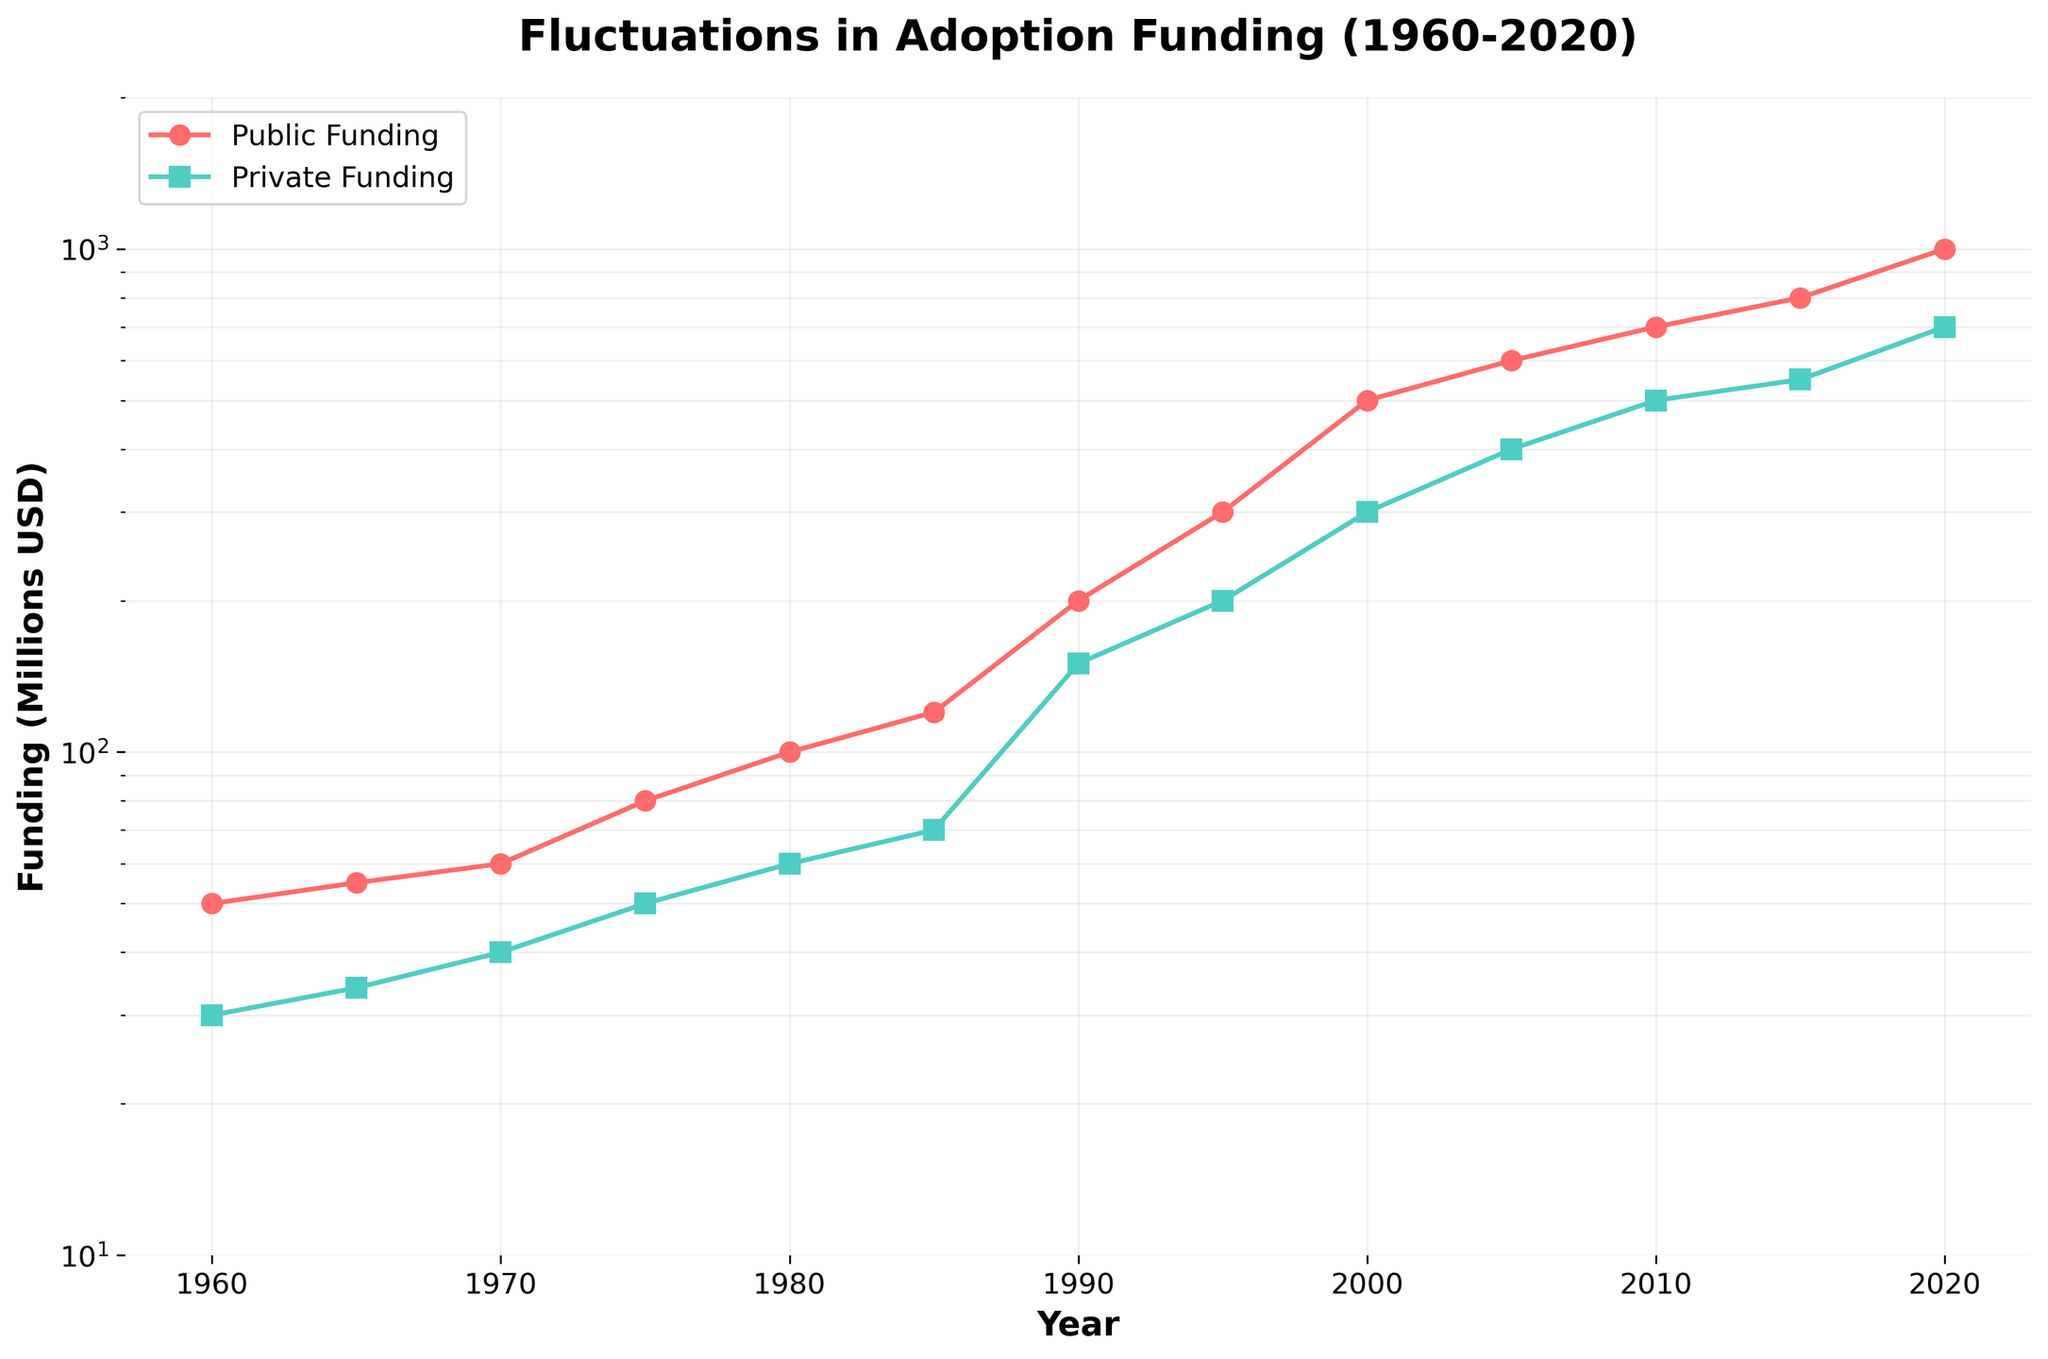What is the title of the figure? The title of the figure is located at the top of the plot and usually gives a brief description of the content being depicted. By referring to the visual information, we can see "Fluctuations in Adoption Funding (1960-2020)" is the title.
Answer: Fluctuations in Adoption Funding (1960-2020) What is the highest amount of public funding recorded and in which year? By examining the line plot for public funding (marked with circles and a red line), we see that the highest point on the y-axis corresponds to the year 2020, where the public funding reaches 1000 million USD.
Answer: 1000 million USD in 2020 How does private funding in 1990 compare to that in 2000? By locating the data points for the years 1990 and 2000 on the line representing private funding (marked with squares and a green line), we observe the values on the y-axis. In 1990, private funding was 150 million USD, and in 2000, it increased to 300 million USD. Hence, private funding doubled from 1990 to 2000.
Answer: Private funding doubled from 1990 to 2000 Between which years did public funding show the most significant increase? To determine the most significant increase, we need to compare the differences in public funding amounts between consecutive years. By observing the steepness of the slopes on the public funding line, the most significant increase is between 1995 and 2000, where public funding rose from 300 to 500 million USD (a 200 million USD increase).
Answer: Between 1995 and 2000 What is the funding difference between public and private sources in 1985? By identifying the values for public and private funding in 1985 on their respective lines, we see that public funding was 120 million USD and private funding was 70 million USD. The difference is calculated as 120 - 70 = 50 million USD.
Answer: 50 million USD Explain the trend in public funding from 1960 to 1975. Observing the plot from 1960 to 1975, we see a continuous, steady increase in public funding. It starts at 50 million USD in 1960 and gradually rises to 80 million USD by 1975. This represents a consistent upward trend without any sharp fluctuations.
Answer: Steady increase Which year had a greater percentage increase in private funding: from 1975 to 1980 or from 1980 to 1985? To find the percentage increase:
1. From 1975 (50 million USD) to 1980 (60 million USD): [(60-50)/50] * 100 = 20%
2. From 1980 (60 million USD) to 1985 (70 million USD): [(70-60)/60] * 100 = 16.67%
The percentage increase is greater from 1975 to 1980.
Answer: 1975 to 1980 What does the logarithmic scale of the y-axis indicate about the rate of change in funding over time? A logarithmic scale compresses large ranges and highlights proportional changes rather than absolute differences. This indicates that the rate of change in funding, especially exponential growth, is more apparent, showing how both public and private funding have increased exponentially over the given years.
Answer: Exponential growth Considering data from 1960 to 2020, is there a year when both public and private funding are equal? By visually examining the plot and comparing the data points for both lines, we see that the lines for public and private funding do not intersect at any point, indicating that there is no year within this range where both funding types are equal.
Answer: No How does the log scale affect the perception of funding growth trends? The log scale reduces the visual gaps between large differences and accentuates relative changes. Thus, while the funding growth may seem more gradual in a linear scale, the log scale reveals the exponential nature of the growth over time, making it easier to perceive smaller variations in lower funding ranges and larger leaps in higher funding ranges.
Answer: Reveals exponential growth and relative changes 